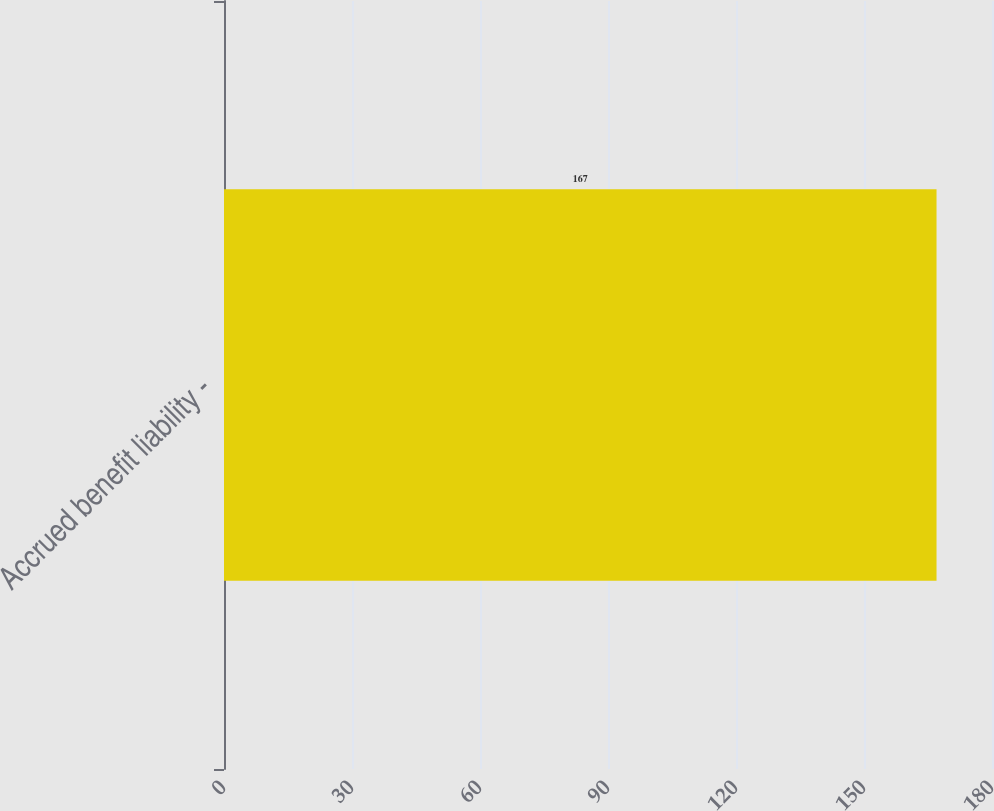Convert chart. <chart><loc_0><loc_0><loc_500><loc_500><bar_chart><fcel>Accrued benefit liability -<nl><fcel>167<nl></chart> 